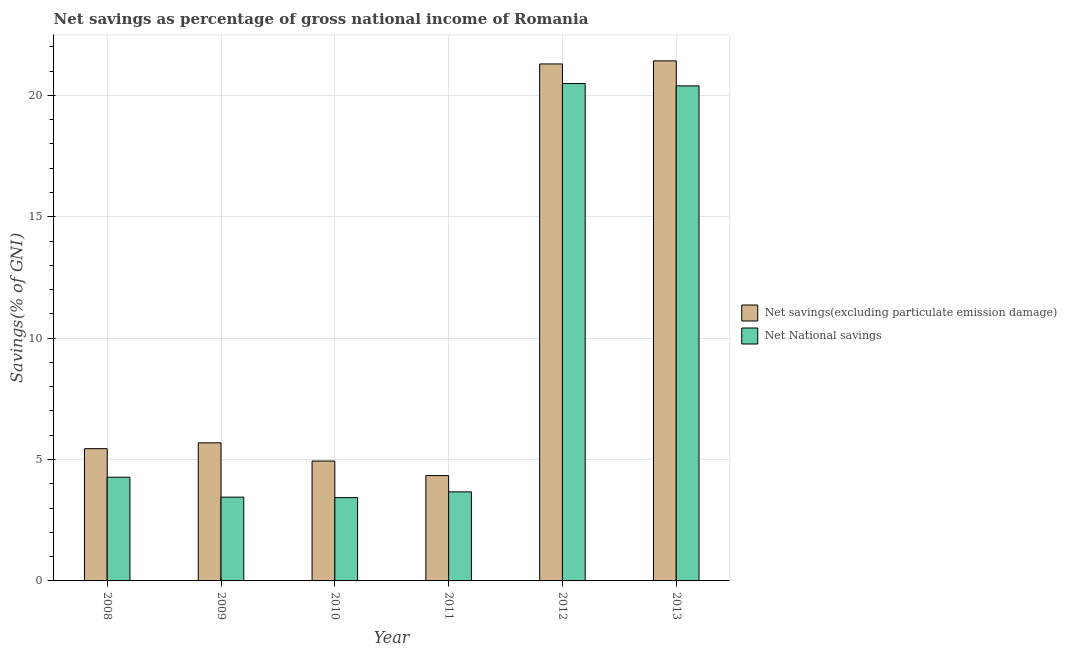Are the number of bars per tick equal to the number of legend labels?
Keep it short and to the point. Yes. How many bars are there on the 2nd tick from the left?
Offer a terse response. 2. What is the label of the 1st group of bars from the left?
Keep it short and to the point. 2008. What is the net savings(excluding particulate emission damage) in 2011?
Make the answer very short. 4.34. Across all years, what is the maximum net national savings?
Give a very brief answer. 20.49. Across all years, what is the minimum net savings(excluding particulate emission damage)?
Your answer should be compact. 4.34. In which year was the net savings(excluding particulate emission damage) maximum?
Keep it short and to the point. 2013. What is the total net savings(excluding particulate emission damage) in the graph?
Offer a terse response. 63.12. What is the difference between the net savings(excluding particulate emission damage) in 2009 and that in 2013?
Make the answer very short. -15.73. What is the difference between the net savings(excluding particulate emission damage) in 2013 and the net national savings in 2010?
Your answer should be very brief. 16.48. What is the average net national savings per year?
Provide a succinct answer. 9.28. In the year 2009, what is the difference between the net national savings and net savings(excluding particulate emission damage)?
Provide a succinct answer. 0. What is the ratio of the net savings(excluding particulate emission damage) in 2010 to that in 2013?
Your answer should be compact. 0.23. Is the net savings(excluding particulate emission damage) in 2008 less than that in 2013?
Offer a very short reply. Yes. Is the difference between the net savings(excluding particulate emission damage) in 2008 and 2013 greater than the difference between the net national savings in 2008 and 2013?
Your answer should be compact. No. What is the difference between the highest and the second highest net national savings?
Give a very brief answer. 0.1. What is the difference between the highest and the lowest net national savings?
Provide a succinct answer. 17.06. In how many years, is the net national savings greater than the average net national savings taken over all years?
Your response must be concise. 2. Is the sum of the net national savings in 2008 and 2013 greater than the maximum net savings(excluding particulate emission damage) across all years?
Ensure brevity in your answer.  Yes. What does the 2nd bar from the left in 2010 represents?
Offer a very short reply. Net National savings. What does the 1st bar from the right in 2008 represents?
Give a very brief answer. Net National savings. Does the graph contain any zero values?
Your answer should be very brief. No. How many legend labels are there?
Offer a terse response. 2. What is the title of the graph?
Provide a succinct answer. Net savings as percentage of gross national income of Romania. What is the label or title of the X-axis?
Keep it short and to the point. Year. What is the label or title of the Y-axis?
Provide a short and direct response. Savings(% of GNI). What is the Savings(% of GNI) of Net savings(excluding particulate emission damage) in 2008?
Make the answer very short. 5.45. What is the Savings(% of GNI) in Net National savings in 2008?
Offer a terse response. 4.27. What is the Savings(% of GNI) in Net savings(excluding particulate emission damage) in 2009?
Provide a succinct answer. 5.69. What is the Savings(% of GNI) in Net National savings in 2009?
Give a very brief answer. 3.45. What is the Savings(% of GNI) of Net savings(excluding particulate emission damage) in 2010?
Offer a very short reply. 4.94. What is the Savings(% of GNI) in Net National savings in 2010?
Make the answer very short. 3.43. What is the Savings(% of GNI) of Net savings(excluding particulate emission damage) in 2011?
Give a very brief answer. 4.34. What is the Savings(% of GNI) in Net National savings in 2011?
Give a very brief answer. 3.67. What is the Savings(% of GNI) of Net savings(excluding particulate emission damage) in 2012?
Your answer should be compact. 21.29. What is the Savings(% of GNI) in Net National savings in 2012?
Offer a terse response. 20.49. What is the Savings(% of GNI) of Net savings(excluding particulate emission damage) in 2013?
Your answer should be compact. 21.42. What is the Savings(% of GNI) in Net National savings in 2013?
Provide a short and direct response. 20.39. Across all years, what is the maximum Savings(% of GNI) of Net savings(excluding particulate emission damage)?
Give a very brief answer. 21.42. Across all years, what is the maximum Savings(% of GNI) in Net National savings?
Offer a terse response. 20.49. Across all years, what is the minimum Savings(% of GNI) of Net savings(excluding particulate emission damage)?
Your answer should be very brief. 4.34. Across all years, what is the minimum Savings(% of GNI) of Net National savings?
Keep it short and to the point. 3.43. What is the total Savings(% of GNI) in Net savings(excluding particulate emission damage) in the graph?
Keep it short and to the point. 63.12. What is the total Savings(% of GNI) in Net National savings in the graph?
Offer a terse response. 55.7. What is the difference between the Savings(% of GNI) of Net savings(excluding particulate emission damage) in 2008 and that in 2009?
Make the answer very short. -0.24. What is the difference between the Savings(% of GNI) of Net National savings in 2008 and that in 2009?
Provide a short and direct response. 0.82. What is the difference between the Savings(% of GNI) in Net savings(excluding particulate emission damage) in 2008 and that in 2010?
Your response must be concise. 0.51. What is the difference between the Savings(% of GNI) in Net National savings in 2008 and that in 2010?
Ensure brevity in your answer.  0.84. What is the difference between the Savings(% of GNI) of Net savings(excluding particulate emission damage) in 2008 and that in 2011?
Provide a short and direct response. 1.11. What is the difference between the Savings(% of GNI) of Net National savings in 2008 and that in 2011?
Provide a short and direct response. 0.6. What is the difference between the Savings(% of GNI) in Net savings(excluding particulate emission damage) in 2008 and that in 2012?
Provide a short and direct response. -15.85. What is the difference between the Savings(% of GNI) in Net National savings in 2008 and that in 2012?
Ensure brevity in your answer.  -16.22. What is the difference between the Savings(% of GNI) in Net savings(excluding particulate emission damage) in 2008 and that in 2013?
Your answer should be very brief. -15.97. What is the difference between the Savings(% of GNI) in Net National savings in 2008 and that in 2013?
Your answer should be compact. -16.12. What is the difference between the Savings(% of GNI) in Net savings(excluding particulate emission damage) in 2009 and that in 2010?
Your answer should be compact. 0.75. What is the difference between the Savings(% of GNI) of Net National savings in 2009 and that in 2010?
Ensure brevity in your answer.  0.02. What is the difference between the Savings(% of GNI) of Net savings(excluding particulate emission damage) in 2009 and that in 2011?
Make the answer very short. 1.35. What is the difference between the Savings(% of GNI) of Net National savings in 2009 and that in 2011?
Keep it short and to the point. -0.22. What is the difference between the Savings(% of GNI) of Net savings(excluding particulate emission damage) in 2009 and that in 2012?
Your answer should be very brief. -15.61. What is the difference between the Savings(% of GNI) in Net National savings in 2009 and that in 2012?
Make the answer very short. -17.04. What is the difference between the Savings(% of GNI) in Net savings(excluding particulate emission damage) in 2009 and that in 2013?
Your response must be concise. -15.73. What is the difference between the Savings(% of GNI) of Net National savings in 2009 and that in 2013?
Give a very brief answer. -16.94. What is the difference between the Savings(% of GNI) in Net savings(excluding particulate emission damage) in 2010 and that in 2011?
Your response must be concise. 0.6. What is the difference between the Savings(% of GNI) in Net National savings in 2010 and that in 2011?
Give a very brief answer. -0.24. What is the difference between the Savings(% of GNI) of Net savings(excluding particulate emission damage) in 2010 and that in 2012?
Offer a very short reply. -16.36. What is the difference between the Savings(% of GNI) of Net National savings in 2010 and that in 2012?
Your response must be concise. -17.06. What is the difference between the Savings(% of GNI) in Net savings(excluding particulate emission damage) in 2010 and that in 2013?
Make the answer very short. -16.48. What is the difference between the Savings(% of GNI) of Net National savings in 2010 and that in 2013?
Offer a very short reply. -16.96. What is the difference between the Savings(% of GNI) of Net savings(excluding particulate emission damage) in 2011 and that in 2012?
Provide a succinct answer. -16.95. What is the difference between the Savings(% of GNI) in Net National savings in 2011 and that in 2012?
Provide a succinct answer. -16.82. What is the difference between the Savings(% of GNI) in Net savings(excluding particulate emission damage) in 2011 and that in 2013?
Offer a terse response. -17.08. What is the difference between the Savings(% of GNI) of Net National savings in 2011 and that in 2013?
Make the answer very short. -16.72. What is the difference between the Savings(% of GNI) of Net savings(excluding particulate emission damage) in 2012 and that in 2013?
Provide a short and direct response. -0.13. What is the difference between the Savings(% of GNI) of Net National savings in 2012 and that in 2013?
Offer a terse response. 0.1. What is the difference between the Savings(% of GNI) of Net savings(excluding particulate emission damage) in 2008 and the Savings(% of GNI) of Net National savings in 2009?
Provide a short and direct response. 2. What is the difference between the Savings(% of GNI) in Net savings(excluding particulate emission damage) in 2008 and the Savings(% of GNI) in Net National savings in 2010?
Keep it short and to the point. 2.02. What is the difference between the Savings(% of GNI) of Net savings(excluding particulate emission damage) in 2008 and the Savings(% of GNI) of Net National savings in 2011?
Ensure brevity in your answer.  1.78. What is the difference between the Savings(% of GNI) of Net savings(excluding particulate emission damage) in 2008 and the Savings(% of GNI) of Net National savings in 2012?
Offer a terse response. -15.04. What is the difference between the Savings(% of GNI) in Net savings(excluding particulate emission damage) in 2008 and the Savings(% of GNI) in Net National savings in 2013?
Ensure brevity in your answer.  -14.94. What is the difference between the Savings(% of GNI) of Net savings(excluding particulate emission damage) in 2009 and the Savings(% of GNI) of Net National savings in 2010?
Provide a short and direct response. 2.26. What is the difference between the Savings(% of GNI) in Net savings(excluding particulate emission damage) in 2009 and the Savings(% of GNI) in Net National savings in 2011?
Ensure brevity in your answer.  2.02. What is the difference between the Savings(% of GNI) of Net savings(excluding particulate emission damage) in 2009 and the Savings(% of GNI) of Net National savings in 2012?
Keep it short and to the point. -14.8. What is the difference between the Savings(% of GNI) of Net savings(excluding particulate emission damage) in 2009 and the Savings(% of GNI) of Net National savings in 2013?
Your response must be concise. -14.7. What is the difference between the Savings(% of GNI) of Net savings(excluding particulate emission damage) in 2010 and the Savings(% of GNI) of Net National savings in 2011?
Your answer should be compact. 1.27. What is the difference between the Savings(% of GNI) of Net savings(excluding particulate emission damage) in 2010 and the Savings(% of GNI) of Net National savings in 2012?
Your answer should be very brief. -15.55. What is the difference between the Savings(% of GNI) of Net savings(excluding particulate emission damage) in 2010 and the Savings(% of GNI) of Net National savings in 2013?
Your answer should be compact. -15.45. What is the difference between the Savings(% of GNI) of Net savings(excluding particulate emission damage) in 2011 and the Savings(% of GNI) of Net National savings in 2012?
Make the answer very short. -16.15. What is the difference between the Savings(% of GNI) of Net savings(excluding particulate emission damage) in 2011 and the Savings(% of GNI) of Net National savings in 2013?
Ensure brevity in your answer.  -16.05. What is the difference between the Savings(% of GNI) in Net savings(excluding particulate emission damage) in 2012 and the Savings(% of GNI) in Net National savings in 2013?
Offer a terse response. 0.9. What is the average Savings(% of GNI) of Net savings(excluding particulate emission damage) per year?
Keep it short and to the point. 10.52. What is the average Savings(% of GNI) of Net National savings per year?
Ensure brevity in your answer.  9.28. In the year 2008, what is the difference between the Savings(% of GNI) of Net savings(excluding particulate emission damage) and Savings(% of GNI) of Net National savings?
Your answer should be very brief. 1.18. In the year 2009, what is the difference between the Savings(% of GNI) in Net savings(excluding particulate emission damage) and Savings(% of GNI) in Net National savings?
Make the answer very short. 2.24. In the year 2010, what is the difference between the Savings(% of GNI) in Net savings(excluding particulate emission damage) and Savings(% of GNI) in Net National savings?
Keep it short and to the point. 1.51. In the year 2011, what is the difference between the Savings(% of GNI) in Net savings(excluding particulate emission damage) and Savings(% of GNI) in Net National savings?
Offer a very short reply. 0.67. In the year 2012, what is the difference between the Savings(% of GNI) in Net savings(excluding particulate emission damage) and Savings(% of GNI) in Net National savings?
Your response must be concise. 0.81. In the year 2013, what is the difference between the Savings(% of GNI) of Net savings(excluding particulate emission damage) and Savings(% of GNI) of Net National savings?
Give a very brief answer. 1.03. What is the ratio of the Savings(% of GNI) in Net savings(excluding particulate emission damage) in 2008 to that in 2009?
Your answer should be very brief. 0.96. What is the ratio of the Savings(% of GNI) of Net National savings in 2008 to that in 2009?
Ensure brevity in your answer.  1.24. What is the ratio of the Savings(% of GNI) of Net savings(excluding particulate emission damage) in 2008 to that in 2010?
Keep it short and to the point. 1.1. What is the ratio of the Savings(% of GNI) in Net National savings in 2008 to that in 2010?
Make the answer very short. 1.24. What is the ratio of the Savings(% of GNI) of Net savings(excluding particulate emission damage) in 2008 to that in 2011?
Offer a terse response. 1.26. What is the ratio of the Savings(% of GNI) in Net National savings in 2008 to that in 2011?
Offer a very short reply. 1.16. What is the ratio of the Savings(% of GNI) of Net savings(excluding particulate emission damage) in 2008 to that in 2012?
Your answer should be compact. 0.26. What is the ratio of the Savings(% of GNI) of Net National savings in 2008 to that in 2012?
Your answer should be very brief. 0.21. What is the ratio of the Savings(% of GNI) of Net savings(excluding particulate emission damage) in 2008 to that in 2013?
Offer a terse response. 0.25. What is the ratio of the Savings(% of GNI) of Net National savings in 2008 to that in 2013?
Provide a succinct answer. 0.21. What is the ratio of the Savings(% of GNI) in Net savings(excluding particulate emission damage) in 2009 to that in 2010?
Keep it short and to the point. 1.15. What is the ratio of the Savings(% of GNI) of Net National savings in 2009 to that in 2010?
Your answer should be very brief. 1.01. What is the ratio of the Savings(% of GNI) in Net savings(excluding particulate emission damage) in 2009 to that in 2011?
Offer a terse response. 1.31. What is the ratio of the Savings(% of GNI) of Net National savings in 2009 to that in 2011?
Make the answer very short. 0.94. What is the ratio of the Savings(% of GNI) of Net savings(excluding particulate emission damage) in 2009 to that in 2012?
Your response must be concise. 0.27. What is the ratio of the Savings(% of GNI) in Net National savings in 2009 to that in 2012?
Your response must be concise. 0.17. What is the ratio of the Savings(% of GNI) of Net savings(excluding particulate emission damage) in 2009 to that in 2013?
Provide a succinct answer. 0.27. What is the ratio of the Savings(% of GNI) in Net National savings in 2009 to that in 2013?
Make the answer very short. 0.17. What is the ratio of the Savings(% of GNI) in Net savings(excluding particulate emission damage) in 2010 to that in 2011?
Offer a terse response. 1.14. What is the ratio of the Savings(% of GNI) of Net National savings in 2010 to that in 2011?
Provide a short and direct response. 0.94. What is the ratio of the Savings(% of GNI) of Net savings(excluding particulate emission damage) in 2010 to that in 2012?
Make the answer very short. 0.23. What is the ratio of the Savings(% of GNI) in Net National savings in 2010 to that in 2012?
Provide a short and direct response. 0.17. What is the ratio of the Savings(% of GNI) of Net savings(excluding particulate emission damage) in 2010 to that in 2013?
Provide a succinct answer. 0.23. What is the ratio of the Savings(% of GNI) in Net National savings in 2010 to that in 2013?
Your response must be concise. 0.17. What is the ratio of the Savings(% of GNI) in Net savings(excluding particulate emission damage) in 2011 to that in 2012?
Your response must be concise. 0.2. What is the ratio of the Savings(% of GNI) of Net National savings in 2011 to that in 2012?
Make the answer very short. 0.18. What is the ratio of the Savings(% of GNI) of Net savings(excluding particulate emission damage) in 2011 to that in 2013?
Provide a short and direct response. 0.2. What is the ratio of the Savings(% of GNI) of Net National savings in 2011 to that in 2013?
Offer a very short reply. 0.18. What is the ratio of the Savings(% of GNI) in Net National savings in 2012 to that in 2013?
Ensure brevity in your answer.  1. What is the difference between the highest and the second highest Savings(% of GNI) of Net savings(excluding particulate emission damage)?
Provide a succinct answer. 0.13. What is the difference between the highest and the second highest Savings(% of GNI) in Net National savings?
Keep it short and to the point. 0.1. What is the difference between the highest and the lowest Savings(% of GNI) of Net savings(excluding particulate emission damage)?
Keep it short and to the point. 17.08. What is the difference between the highest and the lowest Savings(% of GNI) of Net National savings?
Your response must be concise. 17.06. 